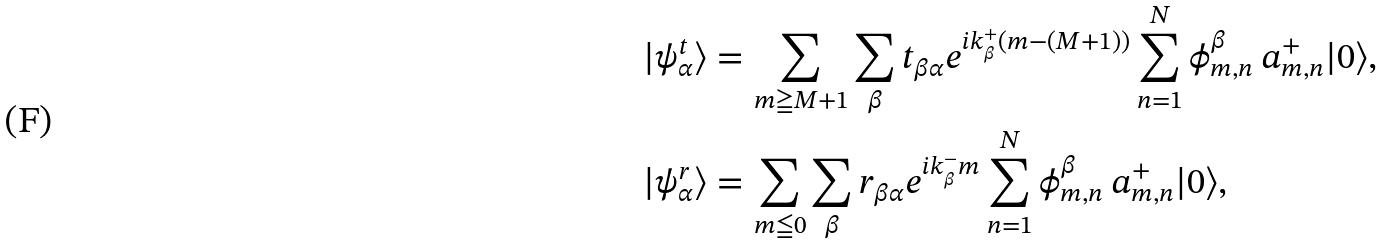Convert formula to latex. <formula><loc_0><loc_0><loc_500><loc_500>| \psi _ { \alpha } ^ { t } \rangle & = \sum _ { m \geqq M + 1 } \sum _ { \beta } t _ { \beta \alpha } e ^ { i k _ { \beta } ^ { + } ( m - ( M + 1 ) ) } \sum _ { n = 1 } ^ { N } \phi _ { m , n } ^ { \beta } \, a _ { m , n } ^ { + } | 0 \rangle , \\ | \psi _ { \alpha } ^ { r } \rangle & = \sum _ { m \leqq 0 } \sum _ { \beta } r _ { \beta \alpha } e ^ { i k _ { \beta } ^ { - } m } \sum _ { n = 1 } ^ { N } \phi _ { m , n } ^ { \beta } \, a _ { m , n } ^ { + } | 0 \rangle ,</formula> 